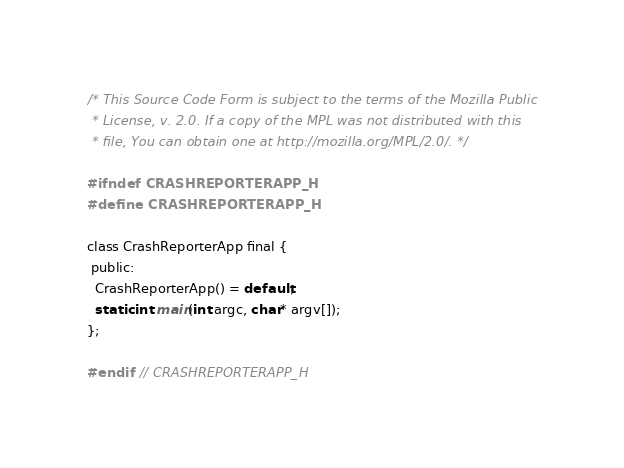Convert code to text. <code><loc_0><loc_0><loc_500><loc_500><_C_>/* This Source Code Form is subject to the terms of the Mozilla Public
 * License, v. 2.0. If a copy of the MPL was not distributed with this
 * file, You can obtain one at http://mozilla.org/MPL/2.0/. */

#ifndef CRASHREPORTERAPP_H
#define CRASHREPORTERAPP_H

class CrashReporterApp final {
 public:
  CrashReporterApp() = default;
  static int main(int argc, char* argv[]);
};

#endif  // CRASHREPORTERAPP_H
</code> 